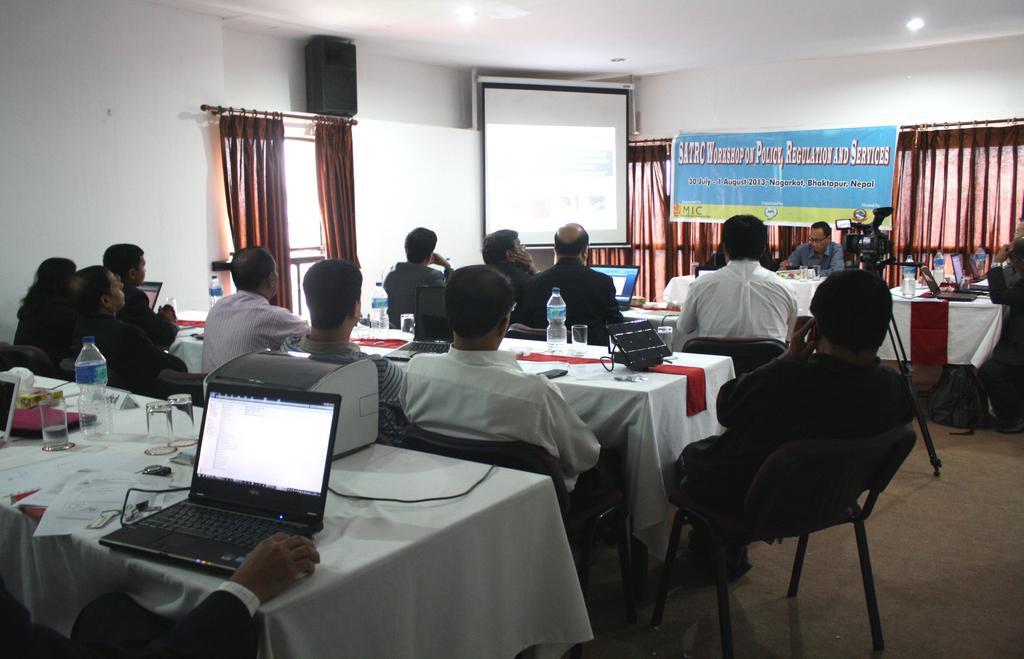Describe this image in one or two sentences. In this image there are group of people sitting on the chair. On the table there is laptop,glass,water bottle. At the back side we can see screen and a banner and there is a camera. On the floor there is a bag. 